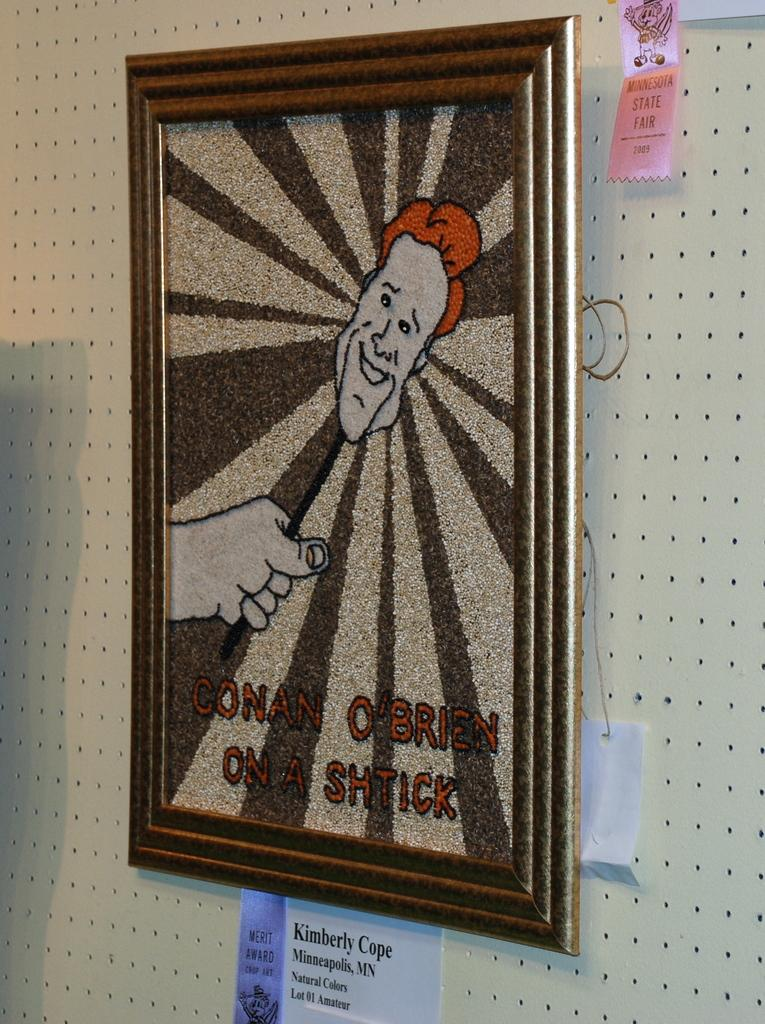What is attached to the wall in the image? There is a frame attached to the wall in the image. What is the color of the frame? The frame is in brown color. What is the color of the wall? The wall is in cream color. What else can be seen attached to the wall in the image? There are papers attached to the wall in the image. What type of silk is draped over the frame in the image? There is no silk present in the image; it only features a frame and papers attached to the wall. What shape is the frame in the image? The provided facts do not mention the shape of the frame, so it cannot be determined from the image. 